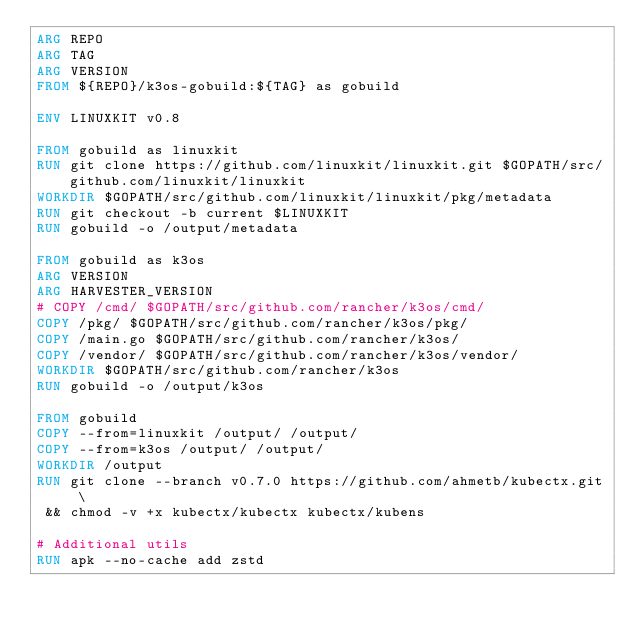<code> <loc_0><loc_0><loc_500><loc_500><_Dockerfile_>ARG REPO
ARG TAG
ARG VERSION
FROM ${REPO}/k3os-gobuild:${TAG} as gobuild

ENV LINUXKIT v0.8

FROM gobuild as linuxkit
RUN git clone https://github.com/linuxkit/linuxkit.git $GOPATH/src/github.com/linuxkit/linuxkit
WORKDIR $GOPATH/src/github.com/linuxkit/linuxkit/pkg/metadata
RUN git checkout -b current $LINUXKIT
RUN gobuild -o /output/metadata

FROM gobuild as k3os
ARG VERSION
ARG HARVESTER_VERSION
# COPY /cmd/ $GOPATH/src/github.com/rancher/k3os/cmd/
COPY /pkg/ $GOPATH/src/github.com/rancher/k3os/pkg/
COPY /main.go $GOPATH/src/github.com/rancher/k3os/
COPY /vendor/ $GOPATH/src/github.com/rancher/k3os/vendor/
WORKDIR $GOPATH/src/github.com/rancher/k3os
RUN gobuild -o /output/k3os

FROM gobuild
COPY --from=linuxkit /output/ /output/
COPY --from=k3os /output/ /output/
WORKDIR /output
RUN git clone --branch v0.7.0 https://github.com/ahmetb/kubectx.git \
 && chmod -v +x kubectx/kubectx kubectx/kubens

# Additional utils
RUN apk --no-cache add zstd
</code> 